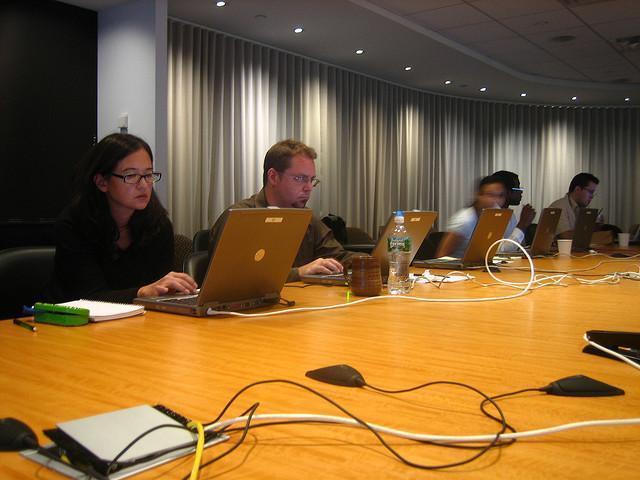How many people have computers?
Give a very brief answer. 5. How many people are there?
Give a very brief answer. 3. How many laptops are there?
Give a very brief answer. 2. 